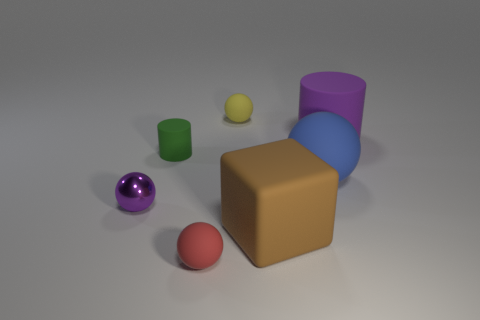Are there any other things that have the same material as the small purple sphere?
Your answer should be very brief. No. Are there any other tiny rubber things that have the same shape as the red object?
Offer a very short reply. Yes. Do the cube and the tiny object in front of the brown cube have the same material?
Provide a succinct answer. Yes. The big rubber ball is what color?
Provide a succinct answer. Blue. How many tiny green things are right of the small matte ball that is in front of the matte object that is on the right side of the blue matte object?
Ensure brevity in your answer.  0. Are there any matte cylinders in front of the large purple thing?
Provide a succinct answer. Yes. How many brown things are the same material as the blue sphere?
Provide a short and direct response. 1. How many objects are either blue metal balls or big brown cubes?
Give a very brief answer. 1. Are there any small brown metallic blocks?
Make the answer very short. No. What is the small object that is right of the tiny rubber sphere in front of the cylinder that is on the right side of the tiny yellow object made of?
Keep it short and to the point. Rubber. 